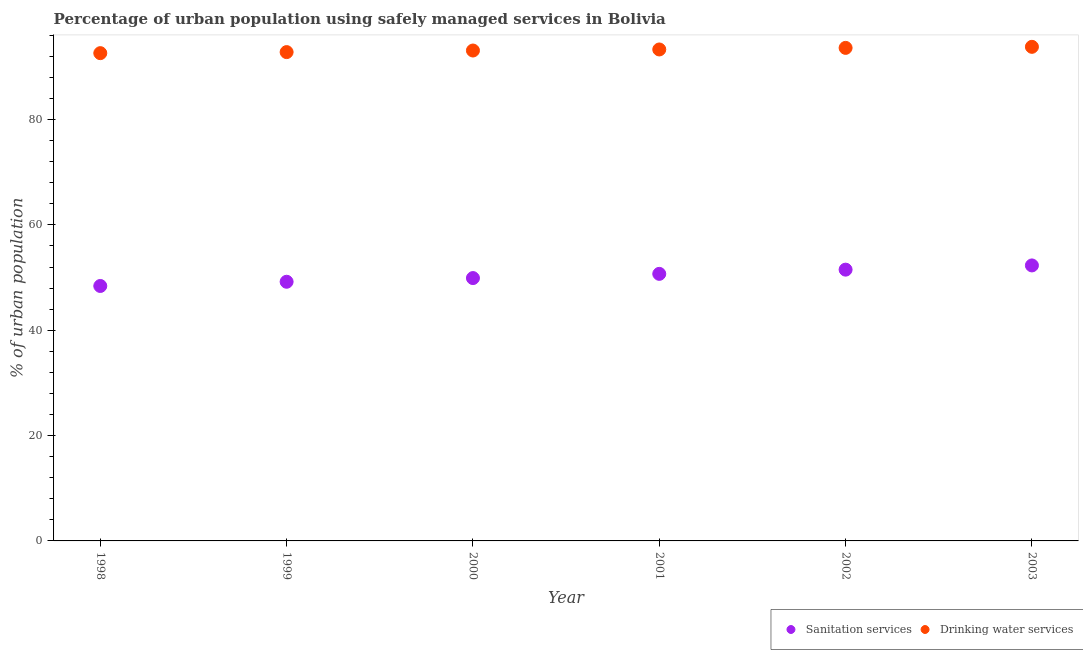Is the number of dotlines equal to the number of legend labels?
Your answer should be compact. Yes. What is the percentage of urban population who used drinking water services in 2000?
Ensure brevity in your answer.  93.1. Across all years, what is the maximum percentage of urban population who used sanitation services?
Offer a very short reply. 52.3. Across all years, what is the minimum percentage of urban population who used sanitation services?
Offer a terse response. 48.4. In which year was the percentage of urban population who used sanitation services maximum?
Offer a terse response. 2003. What is the total percentage of urban population who used sanitation services in the graph?
Your answer should be compact. 302. What is the difference between the percentage of urban population who used drinking water services in 2001 and that in 2002?
Offer a very short reply. -0.3. What is the difference between the percentage of urban population who used sanitation services in 2002 and the percentage of urban population who used drinking water services in 1998?
Offer a very short reply. -41.1. What is the average percentage of urban population who used drinking water services per year?
Make the answer very short. 93.2. In the year 2003, what is the difference between the percentage of urban population who used drinking water services and percentage of urban population who used sanitation services?
Your answer should be compact. 41.5. What is the ratio of the percentage of urban population who used sanitation services in 1998 to that in 1999?
Offer a terse response. 0.98. Is the percentage of urban population who used sanitation services in 1998 less than that in 2002?
Keep it short and to the point. Yes. Is the difference between the percentage of urban population who used drinking water services in 1998 and 2002 greater than the difference between the percentage of urban population who used sanitation services in 1998 and 2002?
Provide a short and direct response. Yes. What is the difference between the highest and the second highest percentage of urban population who used sanitation services?
Give a very brief answer. 0.8. What is the difference between the highest and the lowest percentage of urban population who used drinking water services?
Keep it short and to the point. 1.2. In how many years, is the percentage of urban population who used drinking water services greater than the average percentage of urban population who used drinking water services taken over all years?
Your response must be concise. 3. Does the percentage of urban population who used sanitation services monotonically increase over the years?
Keep it short and to the point. Yes. Is the percentage of urban population who used sanitation services strictly greater than the percentage of urban population who used drinking water services over the years?
Ensure brevity in your answer.  No. Is the percentage of urban population who used drinking water services strictly less than the percentage of urban population who used sanitation services over the years?
Your answer should be very brief. No. Are the values on the major ticks of Y-axis written in scientific E-notation?
Provide a short and direct response. No. Does the graph contain any zero values?
Keep it short and to the point. No. What is the title of the graph?
Make the answer very short. Percentage of urban population using safely managed services in Bolivia. What is the label or title of the Y-axis?
Ensure brevity in your answer.  % of urban population. What is the % of urban population of Sanitation services in 1998?
Provide a short and direct response. 48.4. What is the % of urban population in Drinking water services in 1998?
Offer a very short reply. 92.6. What is the % of urban population in Sanitation services in 1999?
Make the answer very short. 49.2. What is the % of urban population of Drinking water services in 1999?
Make the answer very short. 92.8. What is the % of urban population in Sanitation services in 2000?
Keep it short and to the point. 49.9. What is the % of urban population in Drinking water services in 2000?
Your response must be concise. 93.1. What is the % of urban population in Sanitation services in 2001?
Give a very brief answer. 50.7. What is the % of urban population of Drinking water services in 2001?
Your response must be concise. 93.3. What is the % of urban population of Sanitation services in 2002?
Give a very brief answer. 51.5. What is the % of urban population in Drinking water services in 2002?
Your answer should be compact. 93.6. What is the % of urban population in Sanitation services in 2003?
Your response must be concise. 52.3. What is the % of urban population of Drinking water services in 2003?
Offer a very short reply. 93.8. Across all years, what is the maximum % of urban population in Sanitation services?
Keep it short and to the point. 52.3. Across all years, what is the maximum % of urban population of Drinking water services?
Provide a short and direct response. 93.8. Across all years, what is the minimum % of urban population in Sanitation services?
Your response must be concise. 48.4. Across all years, what is the minimum % of urban population in Drinking water services?
Offer a terse response. 92.6. What is the total % of urban population of Sanitation services in the graph?
Provide a short and direct response. 302. What is the total % of urban population of Drinking water services in the graph?
Ensure brevity in your answer.  559.2. What is the difference between the % of urban population in Sanitation services in 1998 and that in 2000?
Give a very brief answer. -1.5. What is the difference between the % of urban population in Sanitation services in 1998 and that in 2002?
Your response must be concise. -3.1. What is the difference between the % of urban population of Drinking water services in 1998 and that in 2002?
Provide a succinct answer. -1. What is the difference between the % of urban population in Drinking water services in 1998 and that in 2003?
Make the answer very short. -1.2. What is the difference between the % of urban population of Sanitation services in 1999 and that in 2000?
Offer a very short reply. -0.7. What is the difference between the % of urban population in Drinking water services in 1999 and that in 2000?
Offer a very short reply. -0.3. What is the difference between the % of urban population of Sanitation services in 1999 and that in 2001?
Your answer should be compact. -1.5. What is the difference between the % of urban population in Drinking water services in 1999 and that in 2002?
Ensure brevity in your answer.  -0.8. What is the difference between the % of urban population of Drinking water services in 2000 and that in 2002?
Offer a very short reply. -0.5. What is the difference between the % of urban population in Sanitation services in 2000 and that in 2003?
Offer a very short reply. -2.4. What is the difference between the % of urban population in Drinking water services in 2000 and that in 2003?
Your response must be concise. -0.7. What is the difference between the % of urban population in Drinking water services in 2001 and that in 2002?
Provide a succinct answer. -0.3. What is the difference between the % of urban population in Drinking water services in 2001 and that in 2003?
Keep it short and to the point. -0.5. What is the difference between the % of urban population in Sanitation services in 1998 and the % of urban population in Drinking water services in 1999?
Your answer should be compact. -44.4. What is the difference between the % of urban population of Sanitation services in 1998 and the % of urban population of Drinking water services in 2000?
Give a very brief answer. -44.7. What is the difference between the % of urban population of Sanitation services in 1998 and the % of urban population of Drinking water services in 2001?
Provide a succinct answer. -44.9. What is the difference between the % of urban population in Sanitation services in 1998 and the % of urban population in Drinking water services in 2002?
Ensure brevity in your answer.  -45.2. What is the difference between the % of urban population of Sanitation services in 1998 and the % of urban population of Drinking water services in 2003?
Keep it short and to the point. -45.4. What is the difference between the % of urban population in Sanitation services in 1999 and the % of urban population in Drinking water services in 2000?
Offer a terse response. -43.9. What is the difference between the % of urban population in Sanitation services in 1999 and the % of urban population in Drinking water services in 2001?
Offer a terse response. -44.1. What is the difference between the % of urban population in Sanitation services in 1999 and the % of urban population in Drinking water services in 2002?
Make the answer very short. -44.4. What is the difference between the % of urban population in Sanitation services in 1999 and the % of urban population in Drinking water services in 2003?
Keep it short and to the point. -44.6. What is the difference between the % of urban population in Sanitation services in 2000 and the % of urban population in Drinking water services in 2001?
Offer a very short reply. -43.4. What is the difference between the % of urban population of Sanitation services in 2000 and the % of urban population of Drinking water services in 2002?
Provide a succinct answer. -43.7. What is the difference between the % of urban population of Sanitation services in 2000 and the % of urban population of Drinking water services in 2003?
Your answer should be compact. -43.9. What is the difference between the % of urban population in Sanitation services in 2001 and the % of urban population in Drinking water services in 2002?
Provide a short and direct response. -42.9. What is the difference between the % of urban population in Sanitation services in 2001 and the % of urban population in Drinking water services in 2003?
Keep it short and to the point. -43.1. What is the difference between the % of urban population of Sanitation services in 2002 and the % of urban population of Drinking water services in 2003?
Your response must be concise. -42.3. What is the average % of urban population of Sanitation services per year?
Provide a succinct answer. 50.33. What is the average % of urban population of Drinking water services per year?
Give a very brief answer. 93.2. In the year 1998, what is the difference between the % of urban population of Sanitation services and % of urban population of Drinking water services?
Make the answer very short. -44.2. In the year 1999, what is the difference between the % of urban population in Sanitation services and % of urban population in Drinking water services?
Your response must be concise. -43.6. In the year 2000, what is the difference between the % of urban population of Sanitation services and % of urban population of Drinking water services?
Provide a short and direct response. -43.2. In the year 2001, what is the difference between the % of urban population of Sanitation services and % of urban population of Drinking water services?
Provide a short and direct response. -42.6. In the year 2002, what is the difference between the % of urban population in Sanitation services and % of urban population in Drinking water services?
Offer a very short reply. -42.1. In the year 2003, what is the difference between the % of urban population in Sanitation services and % of urban population in Drinking water services?
Offer a terse response. -41.5. What is the ratio of the % of urban population in Sanitation services in 1998 to that in 1999?
Your response must be concise. 0.98. What is the ratio of the % of urban population of Drinking water services in 1998 to that in 1999?
Provide a short and direct response. 1. What is the ratio of the % of urban population of Sanitation services in 1998 to that in 2000?
Offer a very short reply. 0.97. What is the ratio of the % of urban population in Sanitation services in 1998 to that in 2001?
Make the answer very short. 0.95. What is the ratio of the % of urban population in Drinking water services in 1998 to that in 2001?
Your answer should be compact. 0.99. What is the ratio of the % of urban population of Sanitation services in 1998 to that in 2002?
Your response must be concise. 0.94. What is the ratio of the % of urban population of Drinking water services in 1998 to that in 2002?
Your response must be concise. 0.99. What is the ratio of the % of urban population in Sanitation services in 1998 to that in 2003?
Make the answer very short. 0.93. What is the ratio of the % of urban population in Drinking water services in 1998 to that in 2003?
Make the answer very short. 0.99. What is the ratio of the % of urban population of Sanitation services in 1999 to that in 2000?
Give a very brief answer. 0.99. What is the ratio of the % of urban population in Sanitation services in 1999 to that in 2001?
Offer a terse response. 0.97. What is the ratio of the % of urban population in Drinking water services in 1999 to that in 2001?
Your answer should be very brief. 0.99. What is the ratio of the % of urban population in Sanitation services in 1999 to that in 2002?
Your answer should be very brief. 0.96. What is the ratio of the % of urban population in Sanitation services in 1999 to that in 2003?
Provide a succinct answer. 0.94. What is the ratio of the % of urban population in Drinking water services in 1999 to that in 2003?
Make the answer very short. 0.99. What is the ratio of the % of urban population of Sanitation services in 2000 to that in 2001?
Your response must be concise. 0.98. What is the ratio of the % of urban population of Drinking water services in 2000 to that in 2001?
Offer a terse response. 1. What is the ratio of the % of urban population in Sanitation services in 2000 to that in 2002?
Make the answer very short. 0.97. What is the ratio of the % of urban population of Drinking water services in 2000 to that in 2002?
Your answer should be compact. 0.99. What is the ratio of the % of urban population of Sanitation services in 2000 to that in 2003?
Your answer should be very brief. 0.95. What is the ratio of the % of urban population of Drinking water services in 2000 to that in 2003?
Provide a short and direct response. 0.99. What is the ratio of the % of urban population of Sanitation services in 2001 to that in 2002?
Offer a very short reply. 0.98. What is the ratio of the % of urban population in Drinking water services in 2001 to that in 2002?
Your answer should be compact. 1. What is the ratio of the % of urban population of Sanitation services in 2001 to that in 2003?
Make the answer very short. 0.97. What is the ratio of the % of urban population of Drinking water services in 2001 to that in 2003?
Your answer should be very brief. 0.99. What is the ratio of the % of urban population in Sanitation services in 2002 to that in 2003?
Provide a short and direct response. 0.98. What is the ratio of the % of urban population in Drinking water services in 2002 to that in 2003?
Ensure brevity in your answer.  1. What is the difference between the highest and the second highest % of urban population in Sanitation services?
Your answer should be very brief. 0.8. What is the difference between the highest and the second highest % of urban population of Drinking water services?
Offer a terse response. 0.2. 